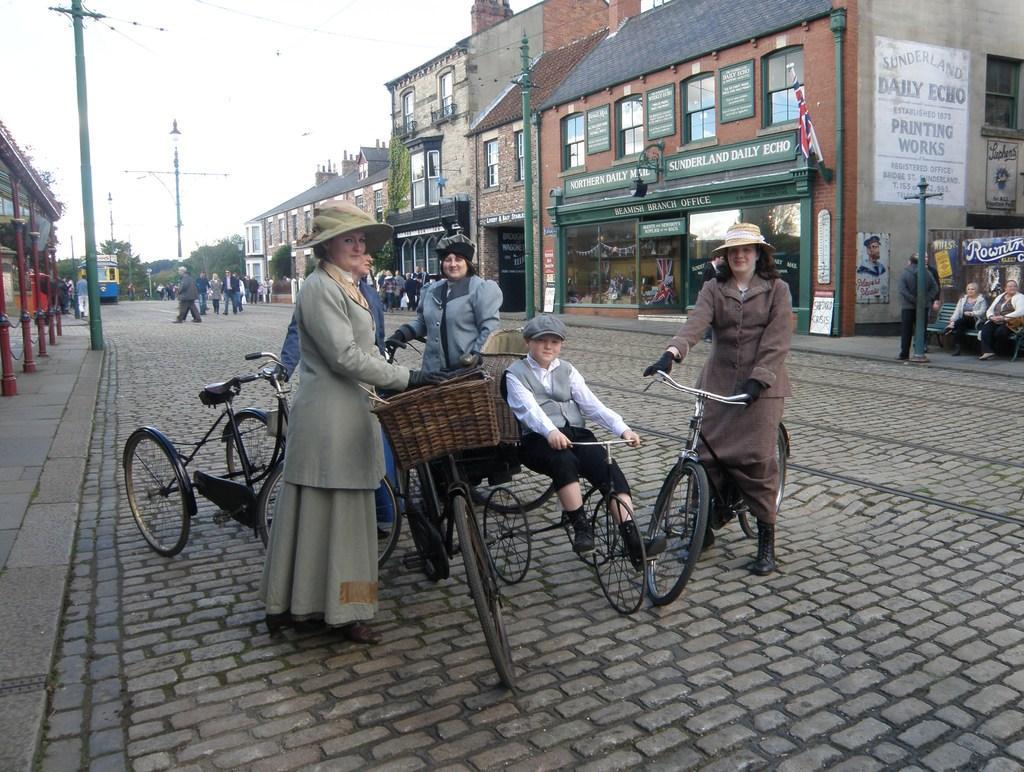Could you give a brief overview of what you see in this image? In this image I see 4 women and a boy and they are on the path with their cycles. In the background I see a lot of buildings and poles and a lot of people over here. 